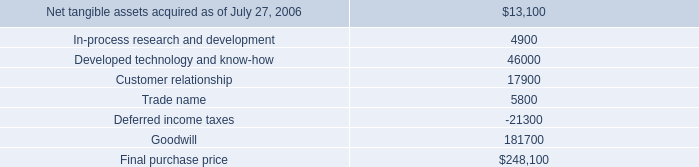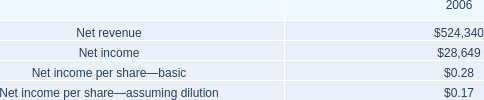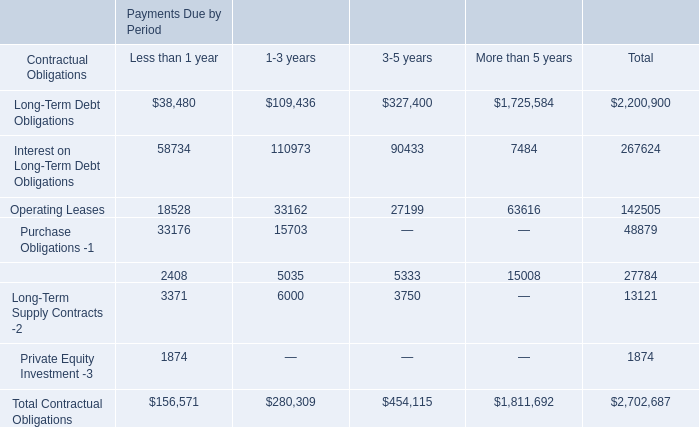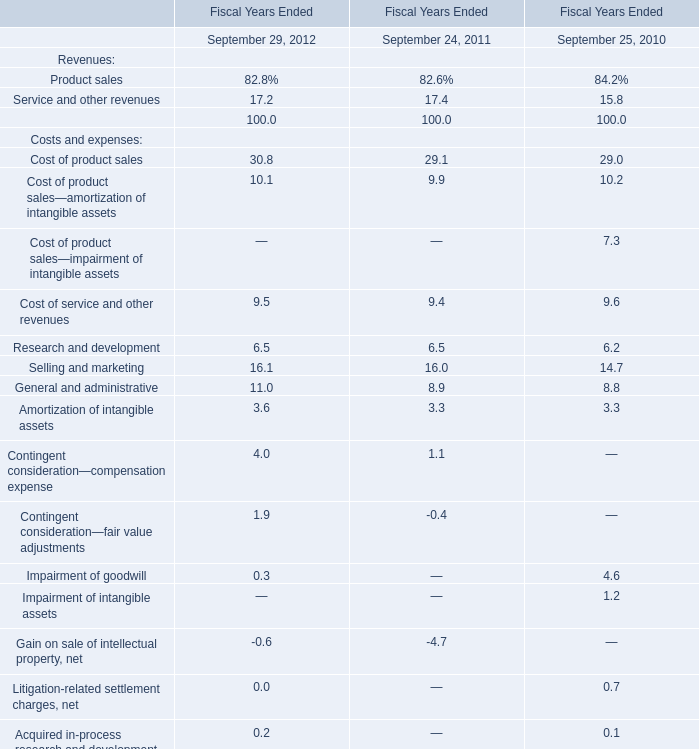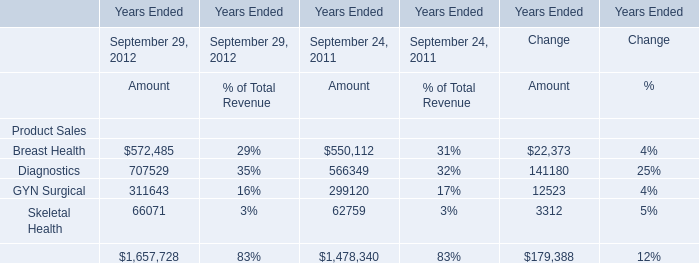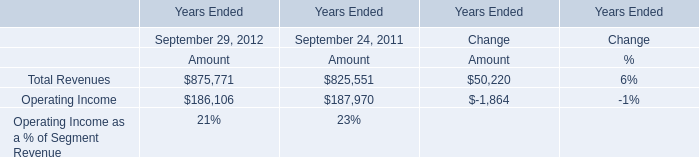What is the average amount of Net tangible assets acquired as of July 27, 2006, and Skeletal Health of Years Ended Change Amount ? 
Computations: ((13100.0 + 3312.0) / 2)
Answer: 8206.0. 